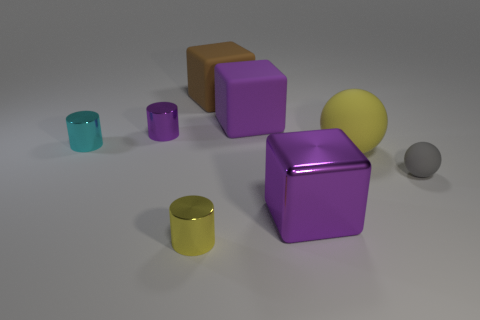Add 1 small brown cubes. How many objects exist? 9 Subtract all cubes. How many objects are left? 5 Subtract 0 yellow blocks. How many objects are left? 8 Subtract all yellow cylinders. Subtract all large blue matte spheres. How many objects are left? 7 Add 1 tiny objects. How many tiny objects are left? 5 Add 5 rubber things. How many rubber things exist? 9 